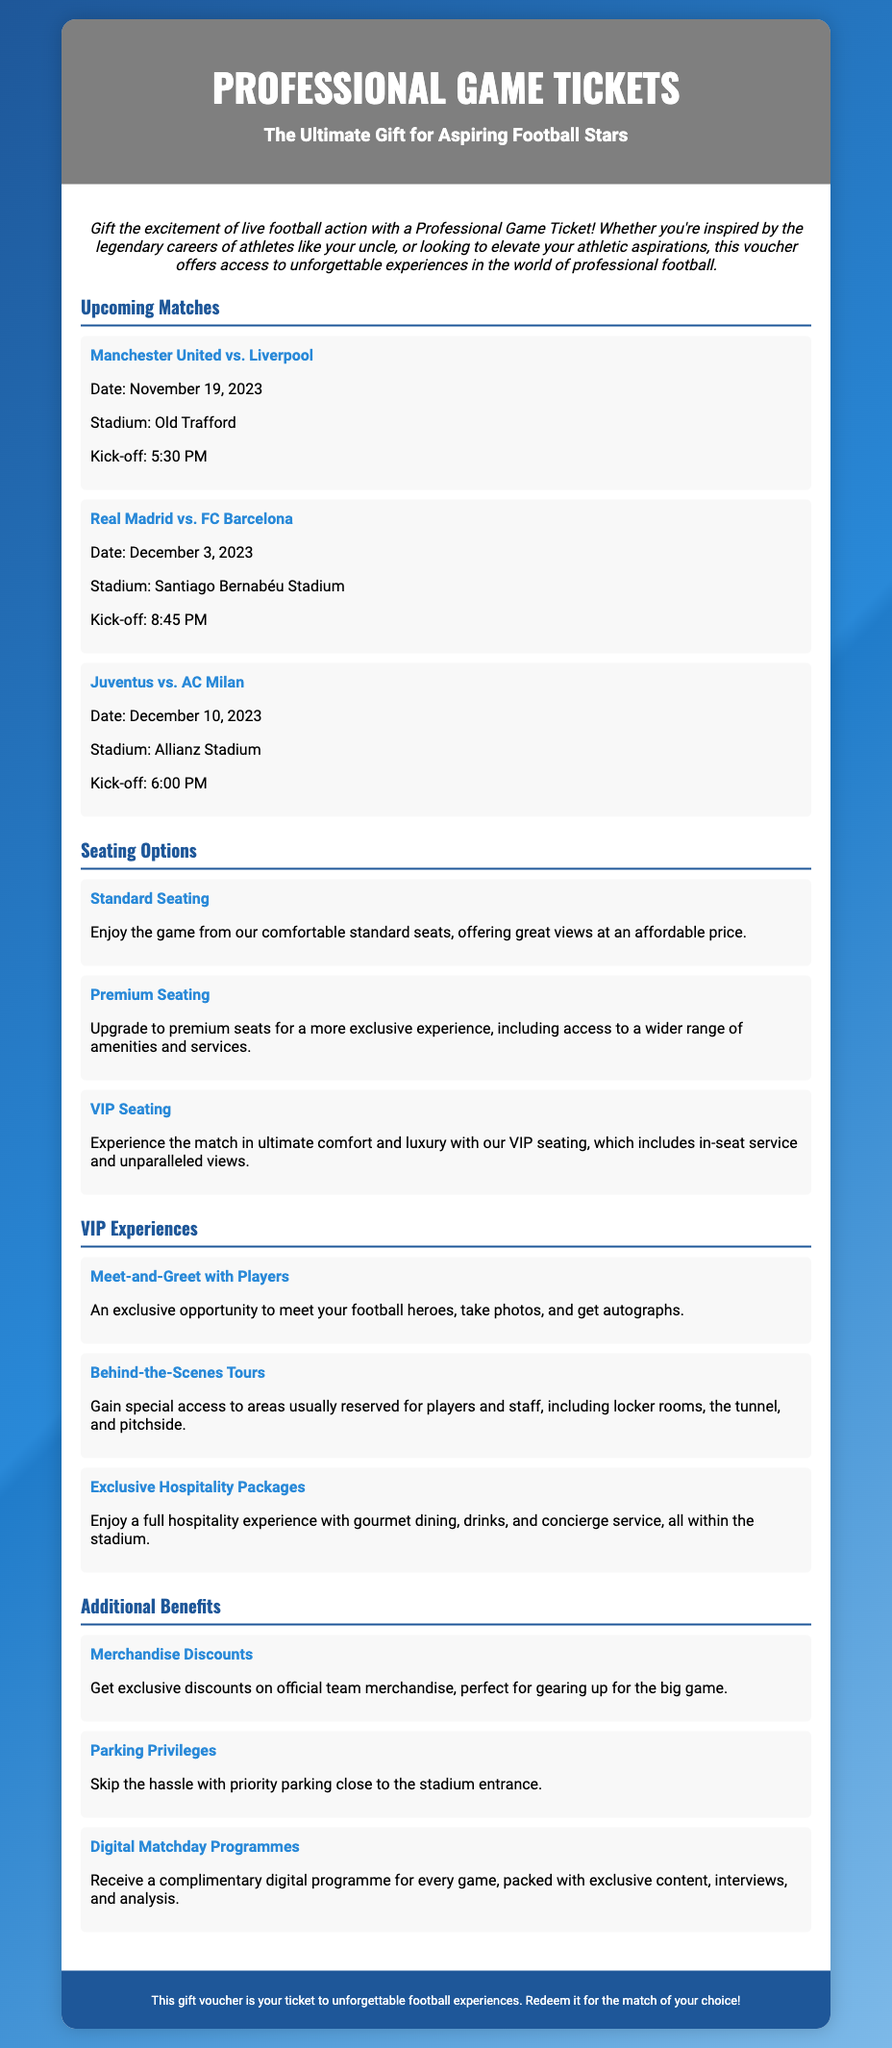what is the title of the voucher? The title of the voucher is prominently displayed at the top of the document and states the type of experience it offers.
Answer: Professional Game Tickets when is the match between Manchester United and Liverpool? The date of the match is specified in the Upcoming Matches section of the document.
Answer: November 19, 2023 what type of seating is described as having in-seat service? The seating option that includes in-seat service is categorized under a specific section that highlights luxurious experiences for attendees.
Answer: VIP Seating what additional benefit allows skipping hassle with parking? This benefit is related to convenience and is mentioned in the Additional Benefits section of the document.
Answer: Parking Privileges what is one of the exclusive VIP experiences offered? This experience is mentioned alongside others to showcase unique opportunities available to voucher holders.
Answer: Meet-and-Greet with Players how many upcoming matches are listed in the document? The number of matches is determined by counting each event detailed in the Upcoming Matches section.
Answer: 3 what is the kick-off time for the Juventus vs. AC Milan match? The kick-off time is provided for each match in the document, clearly noted in the relevant section.
Answer: 6:00 PM what do merchandise discounts pertain to? This benefit is expressed in terms of specific items that users can purchase, denoted within the Additional Benefits section.
Answer: Official team merchandise 